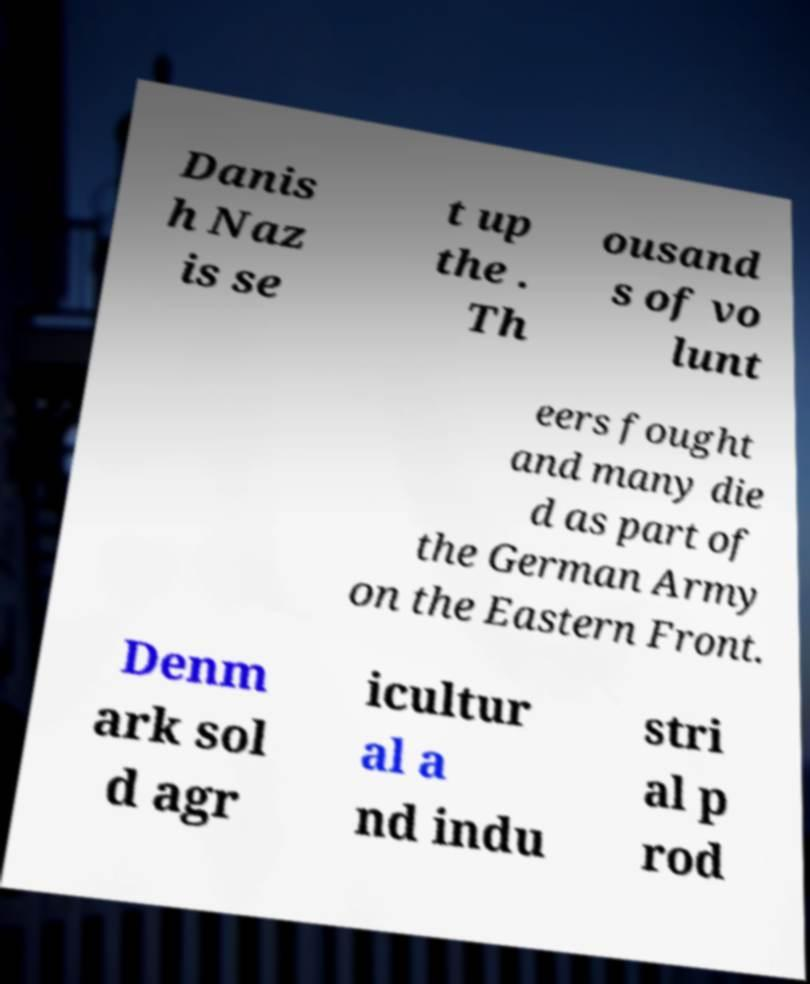Could you assist in decoding the text presented in this image and type it out clearly? Danis h Naz is se t up the . Th ousand s of vo lunt eers fought and many die d as part of the German Army on the Eastern Front. Denm ark sol d agr icultur al a nd indu stri al p rod 